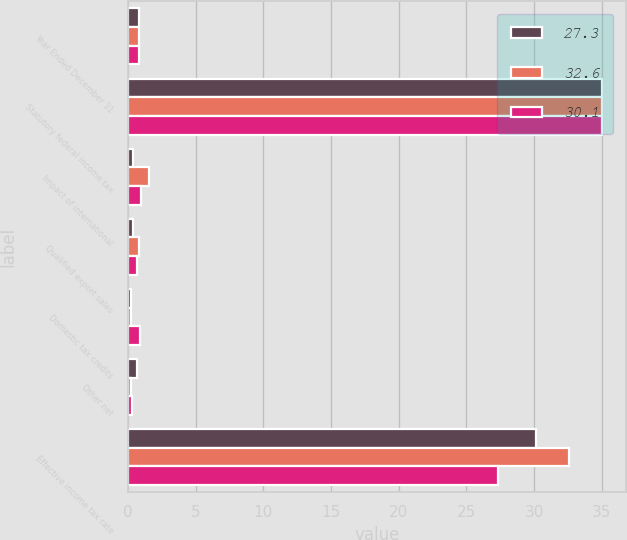Convert chart to OTSL. <chart><loc_0><loc_0><loc_500><loc_500><stacked_bar_chart><ecel><fcel>Year Ended December 31<fcel>Statutory federal income tax<fcel>Impact of international<fcel>Qualified export sales<fcel>Domestic tax credits<fcel>Other net<fcel>Effective income tax rate<nl><fcel>27.3<fcel>0.85<fcel>35<fcel>0.4<fcel>0.4<fcel>0.2<fcel>0.7<fcel>30.1<nl><fcel>32.6<fcel>0.85<fcel>35<fcel>1.6<fcel>0.8<fcel>0.2<fcel>0.2<fcel>32.6<nl><fcel>30.1<fcel>0.85<fcel>35<fcel>1<fcel>0.7<fcel>0.9<fcel>0.3<fcel>27.3<nl></chart> 